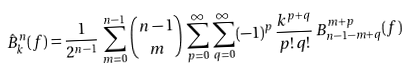<formula> <loc_0><loc_0><loc_500><loc_500>\hat { B } ^ { n } _ { k } ( f ) = \frac { 1 } { 2 ^ { n - 1 } } \, \sum _ { m = 0 } ^ { n - 1 } \, \binom { n - 1 } { m } \, \sum _ { p = 0 } ^ { \infty } \, \sum _ { q = 0 } ^ { \infty } \, ( - 1 ) ^ { p } \, \frac { k ^ { p + q } } { p ! \, q ! } \, B ^ { m + p } _ { n - 1 - m + q } ( f )</formula> 